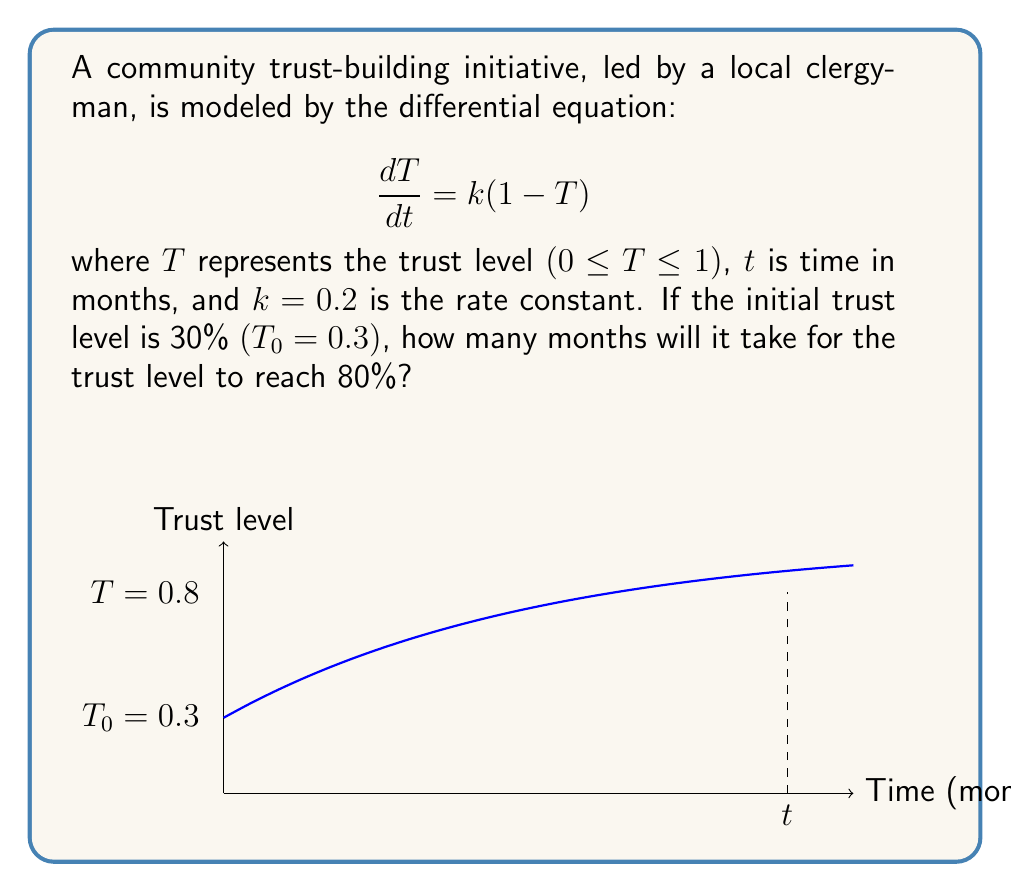Provide a solution to this math problem. Let's solve this problem step by step:

1) The given differential equation is a first-order linear equation:

   $$\frac{dT}{dt} = k(1 - T)$$

2) The solution to this equation is:

   $$T(t) = 1 - (1 - T_0)e^{-kt}$$

   where $T_0$ is the initial trust level.

3) We're given:
   - $k = 0.2$
   - $T_0 = 0.3$
   - We want to find $t$ when $T = 0.8$

4) Let's substitute these values into our equation:

   $$0.8 = 1 - (1 - 0.3)e^{-0.2t}$$

5) Simplify:
   $$0.8 = 1 - 0.7e^{-0.2t}$$

6) Subtract both sides from 1:
   $$0.2 = 0.7e^{-0.2t}$$

7) Divide both sides by 0.7:
   $$\frac{2}{7} = e^{-0.2t}$$

8) Take the natural log of both sides:
   $$\ln(\frac{2}{7}) = -0.2t$$

9) Divide both sides by -0.2:
   $$\frac{\ln(\frac{2}{7})}{-0.2} = t$$

10) Calculate:
    $$t \approx 8.95 \text{ months}$$
Answer: $8.95$ months 